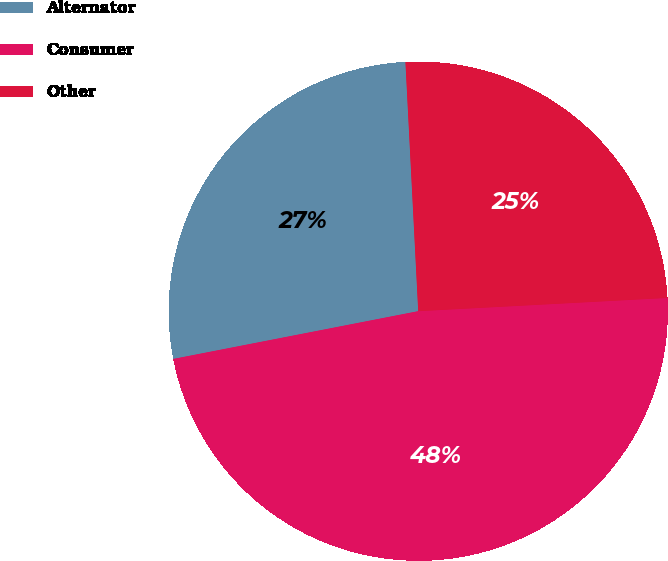Convert chart to OTSL. <chart><loc_0><loc_0><loc_500><loc_500><pie_chart><fcel>Alternator<fcel>Consumer<fcel>Other<nl><fcel>27.25%<fcel>47.78%<fcel>24.97%<nl></chart> 